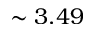Convert formula to latex. <formula><loc_0><loc_0><loc_500><loc_500>\sim 3 . 4 9</formula> 